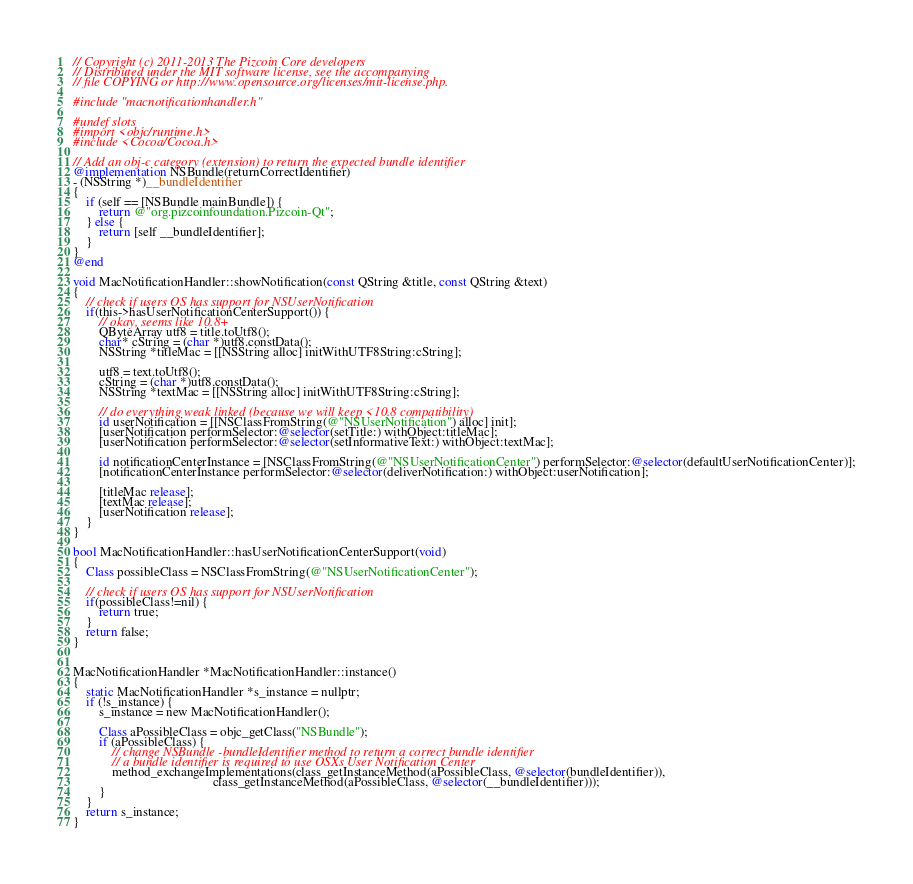Convert code to text. <code><loc_0><loc_0><loc_500><loc_500><_ObjectiveC_>// Copyright (c) 2011-2013 The Pizcoin Core developers
// Distributed under the MIT software license, see the accompanying
// file COPYING or http://www.opensource.org/licenses/mit-license.php.

#include "macnotificationhandler.h"

#undef slots
#import <objc/runtime.h>
#include <Cocoa/Cocoa.h>

// Add an obj-c category (extension) to return the expected bundle identifier
@implementation NSBundle(returnCorrectIdentifier)
- (NSString *)__bundleIdentifier
{
    if (self == [NSBundle mainBundle]) {
        return @"org.pizcoinfoundation.Pizcoin-Qt";
    } else {
        return [self __bundleIdentifier];
    }
}
@end

void MacNotificationHandler::showNotification(const QString &title, const QString &text)
{
    // check if users OS has support for NSUserNotification
    if(this->hasUserNotificationCenterSupport()) {
        // okay, seems like 10.8+
        QByteArray utf8 = title.toUtf8();
        char* cString = (char *)utf8.constData();
        NSString *titleMac = [[NSString alloc] initWithUTF8String:cString];

        utf8 = text.toUtf8();
        cString = (char *)utf8.constData();
        NSString *textMac = [[NSString alloc] initWithUTF8String:cString];

        // do everything weak linked (because we will keep <10.8 compatibility)
        id userNotification = [[NSClassFromString(@"NSUserNotification") alloc] init];
        [userNotification performSelector:@selector(setTitle:) withObject:titleMac];
        [userNotification performSelector:@selector(setInformativeText:) withObject:textMac];

        id notificationCenterInstance = [NSClassFromString(@"NSUserNotificationCenter") performSelector:@selector(defaultUserNotificationCenter)];
        [notificationCenterInstance performSelector:@selector(deliverNotification:) withObject:userNotification];

        [titleMac release];
        [textMac release];
        [userNotification release];
    }
}

bool MacNotificationHandler::hasUserNotificationCenterSupport(void)
{
    Class possibleClass = NSClassFromString(@"NSUserNotificationCenter");

    // check if users OS has support for NSUserNotification
    if(possibleClass!=nil) {
        return true;
    }
    return false;
}


MacNotificationHandler *MacNotificationHandler::instance()
{
    static MacNotificationHandler *s_instance = nullptr;
    if (!s_instance) {
        s_instance = new MacNotificationHandler();
        
        Class aPossibleClass = objc_getClass("NSBundle");
        if (aPossibleClass) {
            // change NSBundle -bundleIdentifier method to return a correct bundle identifier
            // a bundle identifier is required to use OSXs User Notification Center
            method_exchangeImplementations(class_getInstanceMethod(aPossibleClass, @selector(bundleIdentifier)),
                                           class_getInstanceMethod(aPossibleClass, @selector(__bundleIdentifier)));
        }
    }
    return s_instance;
}
</code> 